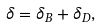Convert formula to latex. <formula><loc_0><loc_0><loc_500><loc_500>\delta = \delta _ { B } + \delta _ { D } ,</formula> 